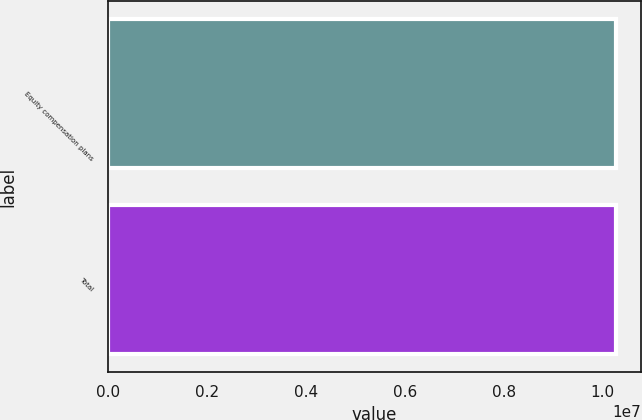<chart> <loc_0><loc_0><loc_500><loc_500><bar_chart><fcel>Equity compensation plans<fcel>Total<nl><fcel>1.02656e+07<fcel>1.02656e+07<nl></chart> 